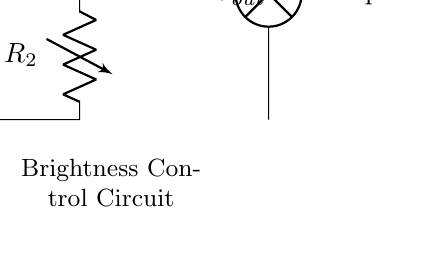What are the components in the circuit? The circuit contains a battery, two resistors (one variable), and a lamp. The battery provides the input voltage, while the resistors are used to create the voltage divider that controls the brightness of the lamp.
Answer: battery, two resistors, lamp What is the purpose of the variable resistor? The variable resistor, labeled as R2, is used to adjust the resistance in the circuit, allowing for the control of the output voltage and thus the brightness of the lamp. By changing its resistance, you can vary the brightness of the lamp accordingly.
Answer: Brightness control What is the output voltage in the circuit? The output voltage, denoted as Vout, is determined by the ratio of the resistances R1 and R2 relative to the input voltage Vin. Since there is no specific numerical value provided for Vin or the resistances, we cannot specify an exact output voltage value. Instead, we can say it varies depending on the resistance settings.
Answer: Variable How does changing R2 affect the lamp brightness? Changing R2 alters the two-resistor voltage divider ratio, which modifies the voltage drop across R2 and consequently the voltage supplied to the lamp. Increasing R2 reduces the voltage across the lamp, dimming it, while decreasing R2 increases the voltage and brightens it.
Answer: It adjusts brightness What type of circuit is used for controlling lamp brightness? The circuit is a basic voltage divider circuit that employs resistive components to control the output voltage based on input voltage and resistances, specifically designed for adjusting brightness in lamps or similar applications.
Answer: Voltage divider What is the input voltage labeled as in the diagram? The input voltage is labeled as Vin in the diagram, representing the voltage supplied by the battery to the circuit. This is the voltage applied across R1 and R2 before any adjustments.
Answer: Vin 